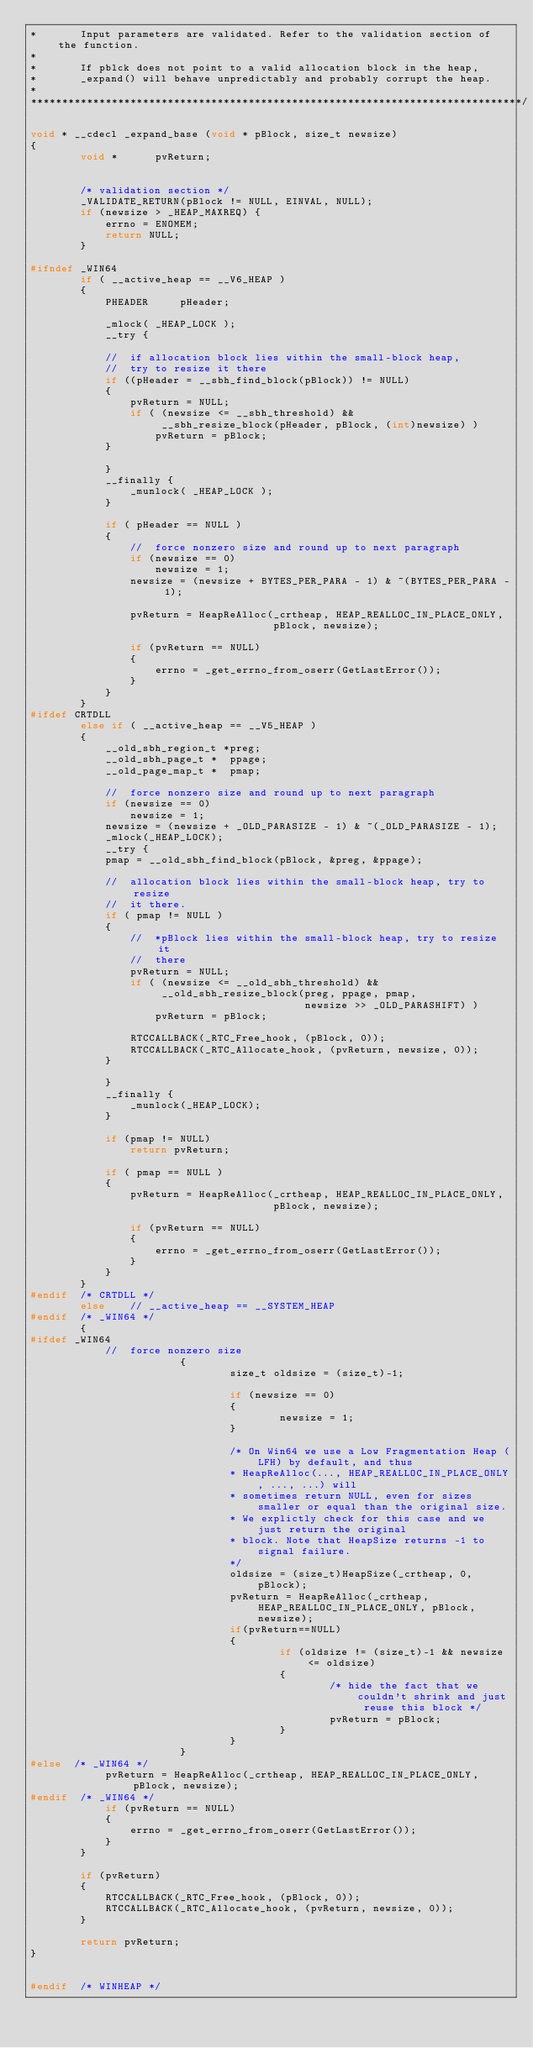<code> <loc_0><loc_0><loc_500><loc_500><_C_>*       Input parameters are validated. Refer to the validation section of the function.
*
*       If pblck does not point to a valid allocation block in the heap,
*       _expand() will behave unpredictably and probably corrupt the heap.
*
*******************************************************************************/

void * __cdecl _expand_base (void * pBlock, size_t newsize)
{
        void *      pvReturn;


        /* validation section */
        _VALIDATE_RETURN(pBlock != NULL, EINVAL, NULL);
        if (newsize > _HEAP_MAXREQ) {
            errno = ENOMEM;
            return NULL;
        }

#ifndef _WIN64
        if ( __active_heap == __V6_HEAP )
        {
            PHEADER     pHeader;

            _mlock( _HEAP_LOCK );
            __try {

            //  if allocation block lies within the small-block heap,
            //  try to resize it there
            if ((pHeader = __sbh_find_block(pBlock)) != NULL)
            {
                pvReturn = NULL;
                if ( (newsize <= __sbh_threshold) &&
                     __sbh_resize_block(pHeader, pBlock, (int)newsize) )
                    pvReturn = pBlock;
            }

            }
            __finally {
                _munlock( _HEAP_LOCK );
            }

            if ( pHeader == NULL )
            {
                //  force nonzero size and round up to next paragraph
                if (newsize == 0)
                    newsize = 1;
                newsize = (newsize + BYTES_PER_PARA - 1) & ~(BYTES_PER_PARA - 1);

                pvReturn = HeapReAlloc(_crtheap, HEAP_REALLOC_IN_PLACE_ONLY,
                                       pBlock, newsize);

                if (pvReturn == NULL)
                {
                    errno = _get_errno_from_oserr(GetLastError());
                }
            }
        }
#ifdef CRTDLL
        else if ( __active_heap == __V5_HEAP )
        {
            __old_sbh_region_t *preg;
            __old_sbh_page_t *  ppage;
            __old_page_map_t *  pmap;

            //  force nonzero size and round up to next paragraph
            if (newsize == 0)
                newsize = 1;
            newsize = (newsize + _OLD_PARASIZE - 1) & ~(_OLD_PARASIZE - 1);
            _mlock(_HEAP_LOCK);
            __try {
            pmap = __old_sbh_find_block(pBlock, &preg, &ppage);

            //  allocation block lies within the small-block heap, try to resize
            //  it there.
            if ( pmap != NULL )
            {
                //  *pBlock lies within the small-block heap, try to resize it
                //  there
                pvReturn = NULL;
                if ( (newsize <= __old_sbh_threshold) &&
                     __old_sbh_resize_block(preg, ppage, pmap,
                                            newsize >> _OLD_PARASHIFT) )
                    pvReturn = pBlock;

                RTCCALLBACK(_RTC_Free_hook, (pBlock, 0));
                RTCCALLBACK(_RTC_Allocate_hook, (pvReturn, newsize, 0));
            }

            }
            __finally {
                _munlock(_HEAP_LOCK);
            }

            if (pmap != NULL)
                return pvReturn;

            if ( pmap == NULL )
            {
                pvReturn = HeapReAlloc(_crtheap, HEAP_REALLOC_IN_PLACE_ONLY,
                                       pBlock, newsize);

                if (pvReturn == NULL)
                {
                    errno = _get_errno_from_oserr(GetLastError());
                }
            }
        }
#endif  /* CRTDLL */
        else    // __active_heap == __SYSTEM_HEAP
#endif  /* _WIN64 */
        {
#ifdef _WIN64
            //  force nonzero size
                        {
                                size_t oldsize = (size_t)-1;

                                if (newsize == 0)
                                {
                                        newsize = 1;
                                }

                                /* On Win64 we use a Low Fragmentation Heap (LFH) by default, and thus
                                * HeapReAlloc(..., HEAP_REALLOC_IN_PLACE_ONLY, ..., ...) will
                                * sometimes return NULL, even for sizes smaller or equal than the original size.
                                * We explictly check for this case and we just return the original
                                * block. Note that HeapSize returns -1 to signal failure.
                                */
                                oldsize = (size_t)HeapSize(_crtheap, 0, pBlock);
                                pvReturn = HeapReAlloc(_crtheap, HEAP_REALLOC_IN_PLACE_ONLY, pBlock, newsize);
                                if(pvReturn==NULL)
                                {
                                        if (oldsize != (size_t)-1 && newsize <= oldsize)
                                        {
                                                /* hide the fact that we couldn't shrink and just reuse this block */
                                                pvReturn = pBlock;
                                        }
                                }
                        }
#else  /* _WIN64 */
            pvReturn = HeapReAlloc(_crtheap, HEAP_REALLOC_IN_PLACE_ONLY, pBlock, newsize);
#endif  /* _WIN64 */
            if (pvReturn == NULL)
            {
                errno = _get_errno_from_oserr(GetLastError());
            }
        }

        if (pvReturn)
        {
            RTCCALLBACK(_RTC_Free_hook, (pBlock, 0));
            RTCCALLBACK(_RTC_Allocate_hook, (pvReturn, newsize, 0));
        }

        return pvReturn;
}


#endif  /* WINHEAP */
</code> 